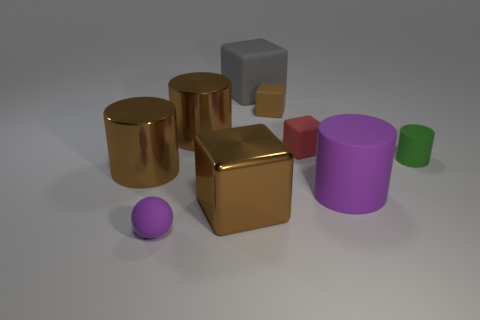Subtract all tiny green rubber cylinders. How many cylinders are left? 3 Add 1 purple objects. How many objects exist? 10 Subtract all brown cylinders. How many cylinders are left? 2 Subtract all blocks. How many objects are left? 5 Subtract 1 cylinders. How many cylinders are left? 3 Subtract all yellow cubes. How many green cylinders are left? 1 Subtract all tiny green rubber balls. Subtract all tiny brown matte blocks. How many objects are left? 8 Add 2 rubber things. How many rubber things are left? 8 Add 2 small green matte things. How many small green matte things exist? 3 Subtract 2 brown blocks. How many objects are left? 7 